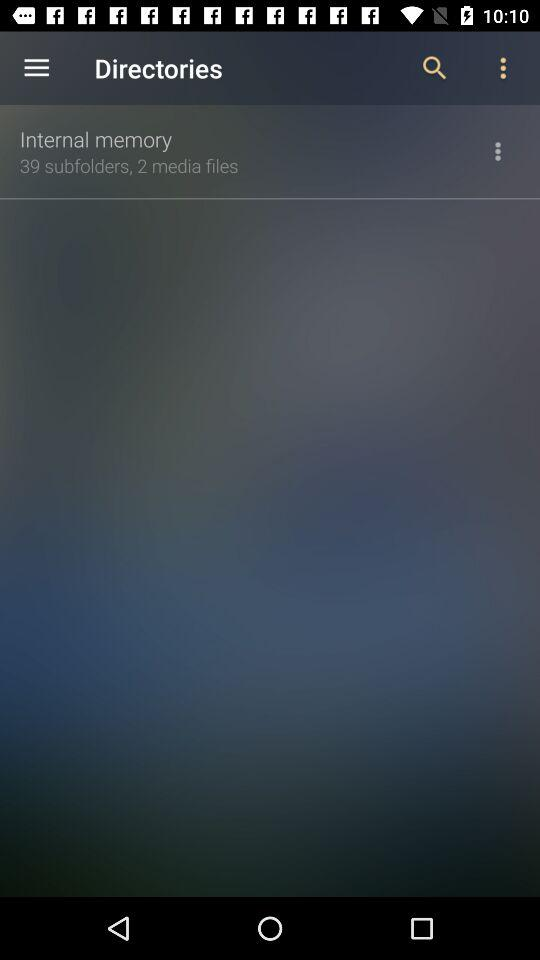What is the number of subfolders present in internal memory? The number of subfolders present in internal memory is 39. 